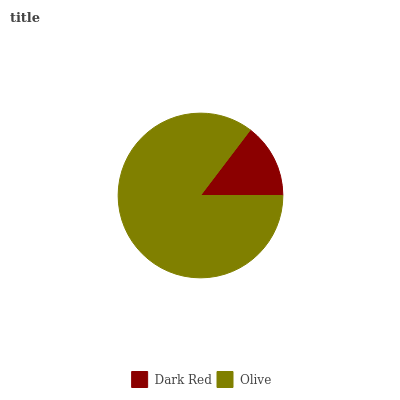Is Dark Red the minimum?
Answer yes or no. Yes. Is Olive the maximum?
Answer yes or no. Yes. Is Olive the minimum?
Answer yes or no. No. Is Olive greater than Dark Red?
Answer yes or no. Yes. Is Dark Red less than Olive?
Answer yes or no. Yes. Is Dark Red greater than Olive?
Answer yes or no. No. Is Olive less than Dark Red?
Answer yes or no. No. Is Olive the high median?
Answer yes or no. Yes. Is Dark Red the low median?
Answer yes or no. Yes. Is Dark Red the high median?
Answer yes or no. No. Is Olive the low median?
Answer yes or no. No. 